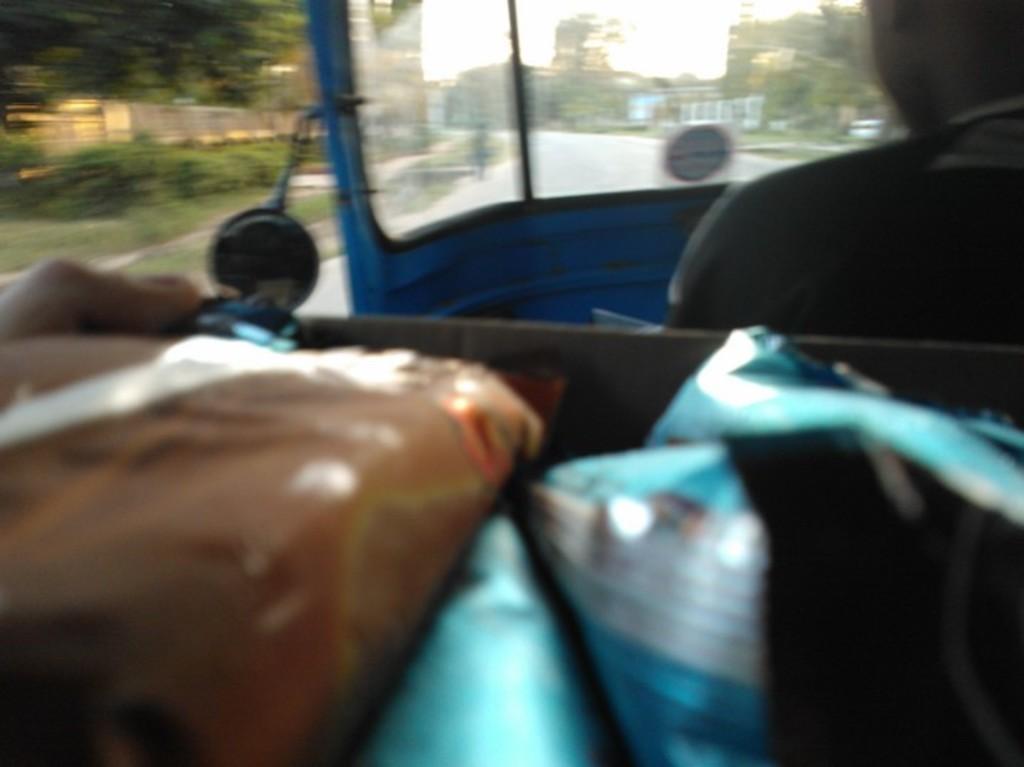Can you describe this image briefly? In this image there are packets in a auto and a person is sitting in it. 